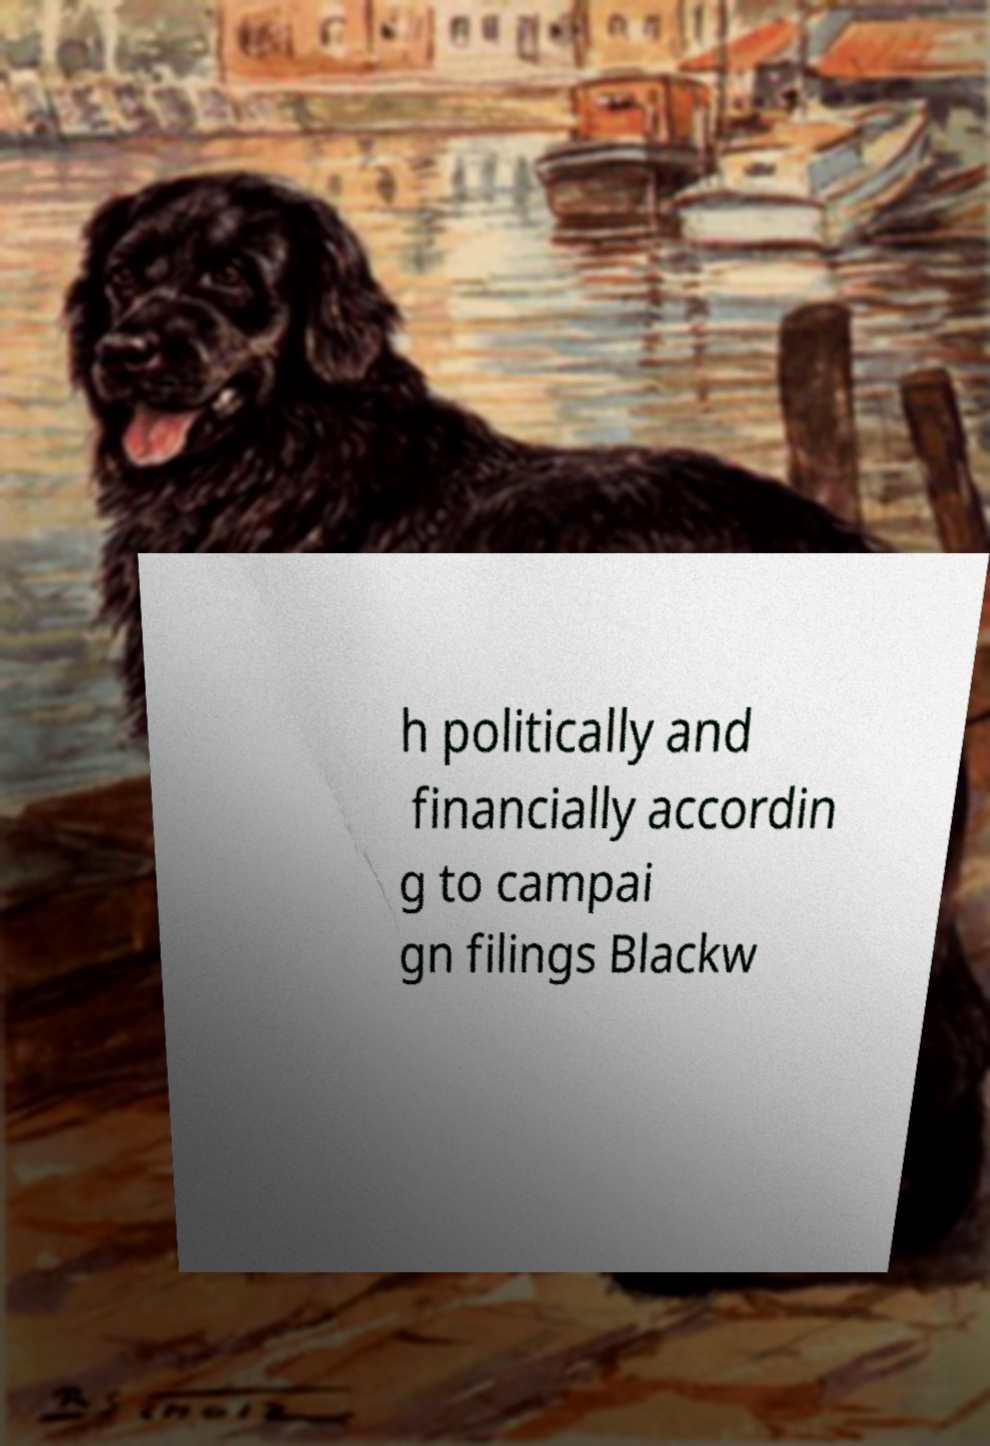Could you extract and type out the text from this image? h politically and financially accordin g to campai gn filings Blackw 